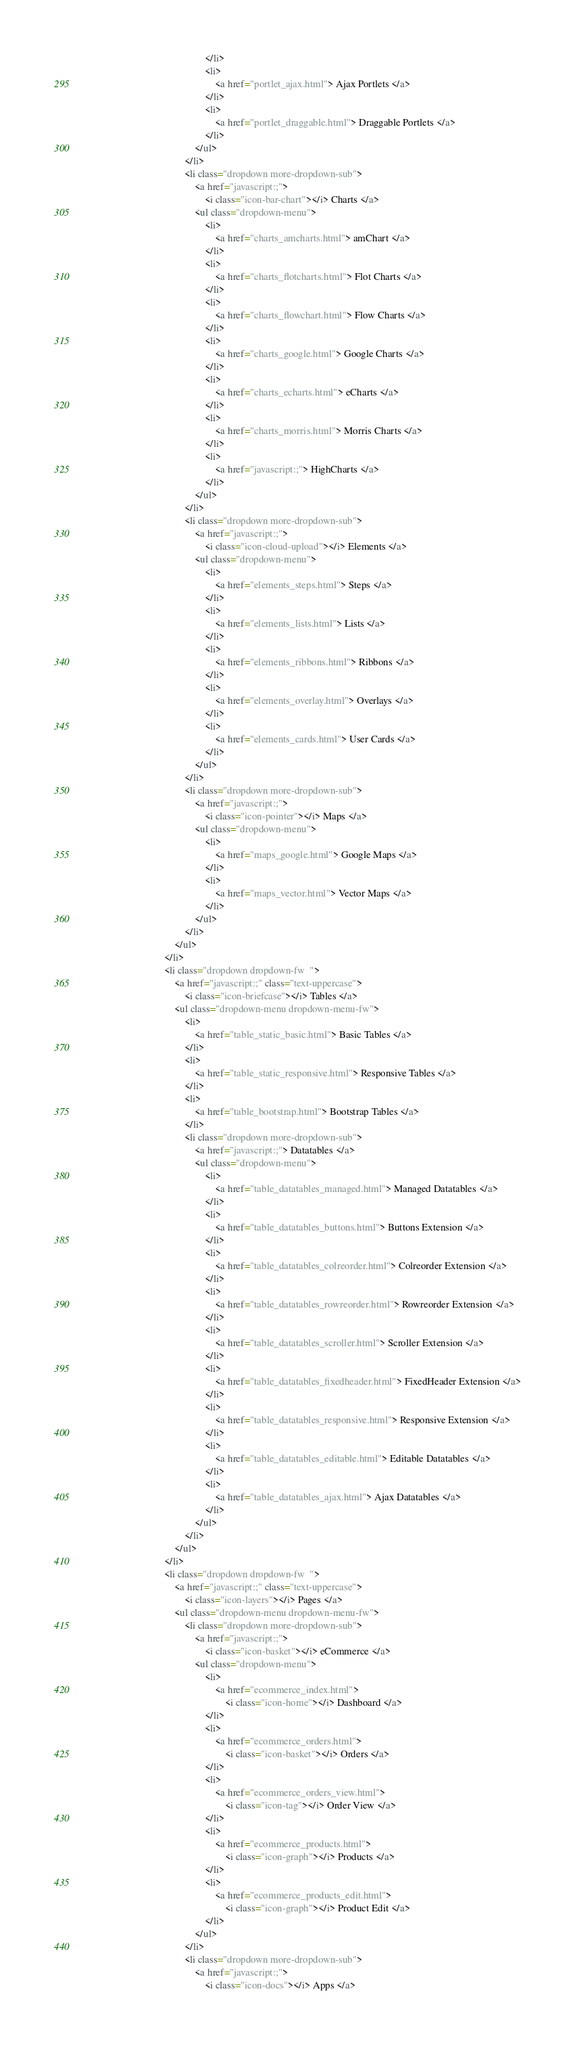Convert code to text. <code><loc_0><loc_0><loc_500><loc_500><_HTML_>                                                </li>
                                                <li>
                                                    <a href="portlet_ajax.html"> Ajax Portlets </a>
                                                </li>
                                                <li>
                                                    <a href="portlet_draggable.html"> Draggable Portlets </a>
                                                </li>
                                            </ul>
                                        </li>
                                        <li class="dropdown more-dropdown-sub">
                                            <a href="javascript:;">
                                                <i class="icon-bar-chart"></i> Charts </a>
                                            <ul class="dropdown-menu">
                                                <li>
                                                    <a href="charts_amcharts.html"> amChart </a>
                                                </li>
                                                <li>
                                                    <a href="charts_flotcharts.html"> Flot Charts </a>
                                                </li>
                                                <li>
                                                    <a href="charts_flowchart.html"> Flow Charts </a>
                                                </li>
                                                <li>
                                                    <a href="charts_google.html"> Google Charts </a>
                                                </li>
                                                <li>
                                                    <a href="charts_echarts.html"> eCharts </a>
                                                </li>
                                                <li>
                                                    <a href="charts_morris.html"> Morris Charts </a>
                                                </li>
                                                <li>
                                                    <a href="javascript:;"> HighCharts </a>
                                                </li>
                                            </ul>
                                        </li>
                                        <li class="dropdown more-dropdown-sub">
                                            <a href="javascript:;">
                                                <i class="icon-cloud-upload"></i> Elements </a>
                                            <ul class="dropdown-menu">
                                                <li>
                                                    <a href="elements_steps.html"> Steps </a>
                                                </li>
                                                <li>
                                                    <a href="elements_lists.html"> Lists </a>
                                                </li>
                                                <li>
                                                    <a href="elements_ribbons.html"> Ribbons </a>
                                                </li>
                                                <li>
                                                    <a href="elements_overlay.html"> Overlays </a>
                                                </li>
                                                <li>
                                                    <a href="elements_cards.html"> User Cards </a>
                                                </li>
                                            </ul>
                                        </li>
                                        <li class="dropdown more-dropdown-sub">
                                            <a href="javascript:;">
                                                <i class="icon-pointer"></i> Maps </a>
                                            <ul class="dropdown-menu">
                                                <li>
                                                    <a href="maps_google.html"> Google Maps </a>
                                                </li>
                                                <li>
                                                    <a href="maps_vector.html"> Vector Maps </a>
                                                </li>
                                            </ul>
                                        </li>
                                    </ul>
                                </li>
                                <li class="dropdown dropdown-fw  ">
                                    <a href="javascript:;" class="text-uppercase">
                                        <i class="icon-briefcase"></i> Tables </a>
                                    <ul class="dropdown-menu dropdown-menu-fw">
                                        <li>
                                            <a href="table_static_basic.html"> Basic Tables </a>
                                        </li>
                                        <li>
                                            <a href="table_static_responsive.html"> Responsive Tables </a>
                                        </li>
                                        <li>
                                            <a href="table_bootstrap.html"> Bootstrap Tables </a>
                                        </li>
                                        <li class="dropdown more-dropdown-sub">
                                            <a href="javascript:;"> Datatables </a>
                                            <ul class="dropdown-menu">
                                                <li>
                                                    <a href="table_datatables_managed.html"> Managed Datatables </a>
                                                </li>
                                                <li>
                                                    <a href="table_datatables_buttons.html"> Buttons Extension </a>
                                                </li>
                                                <li>
                                                    <a href="table_datatables_colreorder.html"> Colreorder Extension </a>
                                                </li>
                                                <li>
                                                    <a href="table_datatables_rowreorder.html"> Rowreorder Extension </a>
                                                </li>
                                                <li>
                                                    <a href="table_datatables_scroller.html"> Scroller Extension </a>
                                                </li>
                                                <li>
                                                    <a href="table_datatables_fixedheader.html"> FixedHeader Extension </a>
                                                </li>
                                                <li>
                                                    <a href="table_datatables_responsive.html"> Responsive Extension </a>
                                                </li>
                                                <li>
                                                    <a href="table_datatables_editable.html"> Editable Datatables </a>
                                                </li>
                                                <li>
                                                    <a href="table_datatables_ajax.html"> Ajax Datatables </a>
                                                </li>
                                            </ul>
                                        </li>
                                    </ul>
                                </li>
                                <li class="dropdown dropdown-fw  ">
                                    <a href="javascript:;" class="text-uppercase">
                                        <i class="icon-layers"></i> Pages </a>
                                    <ul class="dropdown-menu dropdown-menu-fw">
                                        <li class="dropdown more-dropdown-sub">
                                            <a href="javascript:;">
                                                <i class="icon-basket"></i> eCommerce </a>
                                            <ul class="dropdown-menu">
                                                <li>
                                                    <a href="ecommerce_index.html">
                                                        <i class="icon-home"></i> Dashboard </a>
                                                </li>
                                                <li>
                                                    <a href="ecommerce_orders.html">
                                                        <i class="icon-basket"></i> Orders </a>
                                                </li>
                                                <li>
                                                    <a href="ecommerce_orders_view.html">
                                                        <i class="icon-tag"></i> Order View </a>
                                                </li>
                                                <li>
                                                    <a href="ecommerce_products.html">
                                                        <i class="icon-graph"></i> Products </a>
                                                </li>
                                                <li>
                                                    <a href="ecommerce_products_edit.html">
                                                        <i class="icon-graph"></i> Product Edit </a>
                                                </li>
                                            </ul>
                                        </li>
                                        <li class="dropdown more-dropdown-sub">
                                            <a href="javascript:;">
                                                <i class="icon-docs"></i> Apps </a></code> 